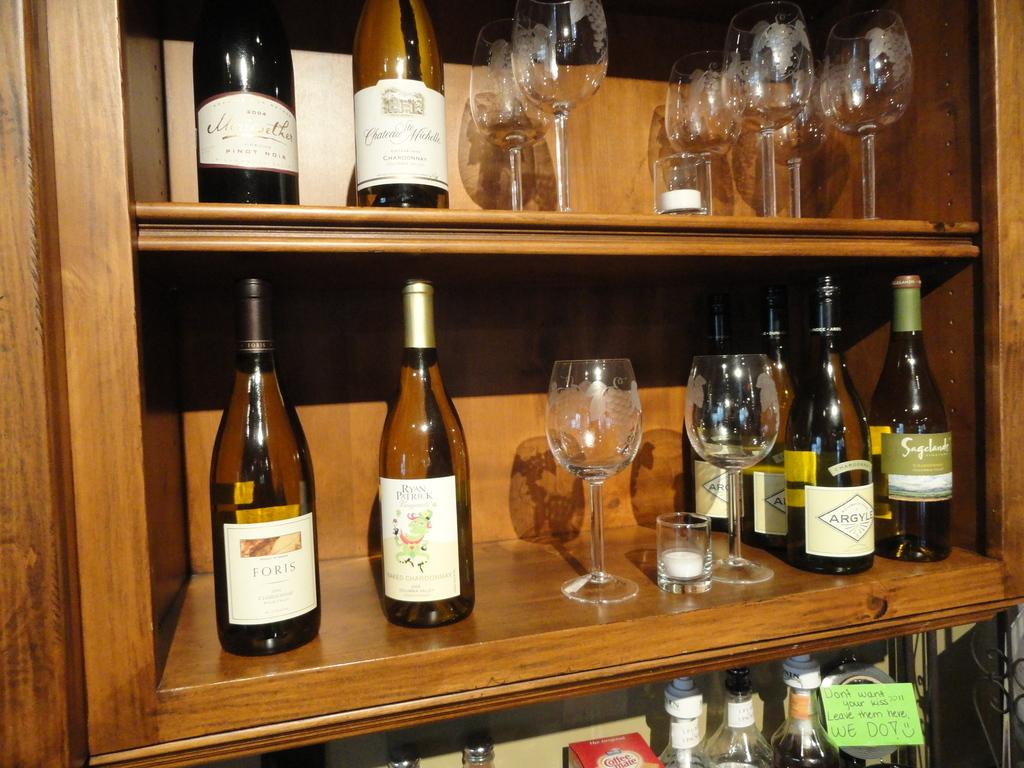Provide a one-sentence caption for the provided image. A great mix of different wines including Foris and some wine glasses. 